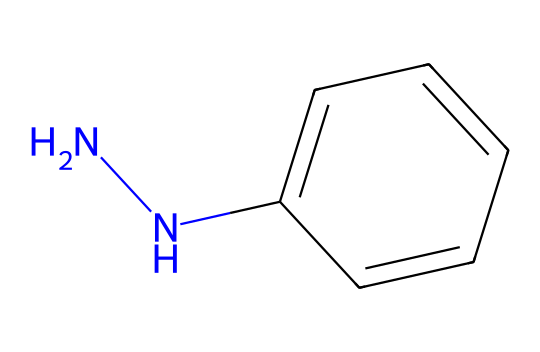What is the name of this chemical? The chemical is identified by its SMILES notation, which reveals its structure. The notation indicates the presence of a hydrazine group (NN) and a benzene ring (c1ccccc1). This corresponds to phenylhydrazine, where a hydrazine is attached to a phenyl group.
Answer: phenylhydrazine How many nitrogen atoms are present in this chemical? The SMILES indicates the presence of "NN," meaning there are two nitrogen atoms in the hydrazine part of the structure.
Answer: 2 What is the functional group of this chemical? The "NN" part of the SMILES represents a hydrazine functional group. This classification is determined by its nitrogen-nitrogen bond characteristic of hydrazines.
Answer: hydrazine Is this chemical aromatic? The structure includes a benzene ring, which is defined as a cyclic structure with alternating double bonds, confirming that it is indeed aromatic.
Answer: yes What type of reactions can this chemical participate in? Phenylhydrazine can participate in various organic reactions such as nucleophilic substitution, especially due to its hydrazine component, and can form hydrazones with carbonyl compounds.
Answer: nucleophilic substitution What color might this chemical impart in a photographic context? Phenylhydrazine derivatives can lead to color changes in photographs due to their reactivity with light-sensitive materials, often resulting in a range of hues in photographic images depending on the compounds used.
Answer: varied hues What is the role of this chemical in photographic chemicals? Phenylhydrazine is commonly used as a reducing agent in photographic development processes, aiding in the formation of images by reducing silver ions to metallic silver.
Answer: reducing agent 